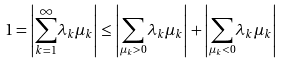<formula> <loc_0><loc_0><loc_500><loc_500>1 = \left | \underset { k = 1 } { \overset { \infty } { \sum } } \lambda _ { k } \mu _ { k } \right | \leq \left | \underset { \mu _ { k } > 0 } { \sum } \lambda _ { k } \mu _ { k } \right | + \left | \underset { \mu _ { k } < 0 } { \sum } \lambda _ { k } \mu _ { k } \right |</formula> 